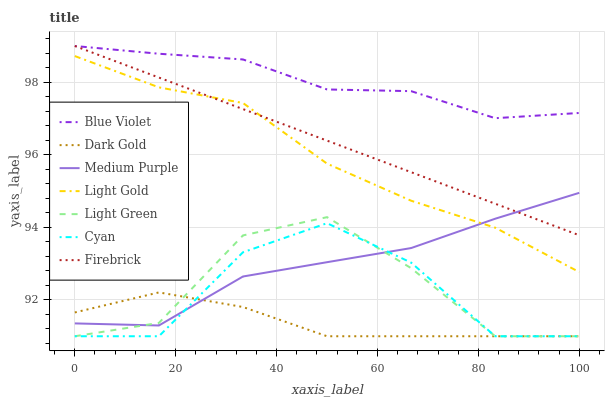Does Dark Gold have the minimum area under the curve?
Answer yes or no. Yes. Does Blue Violet have the maximum area under the curve?
Answer yes or no. Yes. Does Firebrick have the minimum area under the curve?
Answer yes or no. No. Does Firebrick have the maximum area under the curve?
Answer yes or no. No. Is Firebrick the smoothest?
Answer yes or no. Yes. Is Cyan the roughest?
Answer yes or no. Yes. Is Medium Purple the smoothest?
Answer yes or no. No. Is Medium Purple the roughest?
Answer yes or no. No. Does Firebrick have the lowest value?
Answer yes or no. No. Does Blue Violet have the highest value?
Answer yes or no. Yes. Does Medium Purple have the highest value?
Answer yes or no. No. Is Dark Gold less than Light Gold?
Answer yes or no. Yes. Is Blue Violet greater than Dark Gold?
Answer yes or no. Yes. Does Medium Purple intersect Light Gold?
Answer yes or no. Yes. Is Medium Purple less than Light Gold?
Answer yes or no. No. Is Medium Purple greater than Light Gold?
Answer yes or no. No. Does Dark Gold intersect Light Gold?
Answer yes or no. No. 